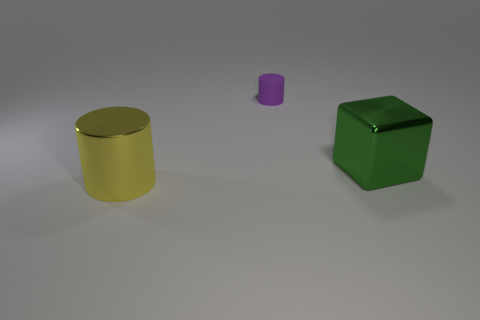Add 3 large metal blocks. How many objects exist? 6 Subtract all cylinders. How many objects are left? 1 Subtract 0 purple balls. How many objects are left? 3 Subtract all big purple objects. Subtract all big things. How many objects are left? 1 Add 3 large yellow metallic cylinders. How many large yellow metallic cylinders are left? 4 Add 1 yellow metallic things. How many yellow metallic things exist? 2 